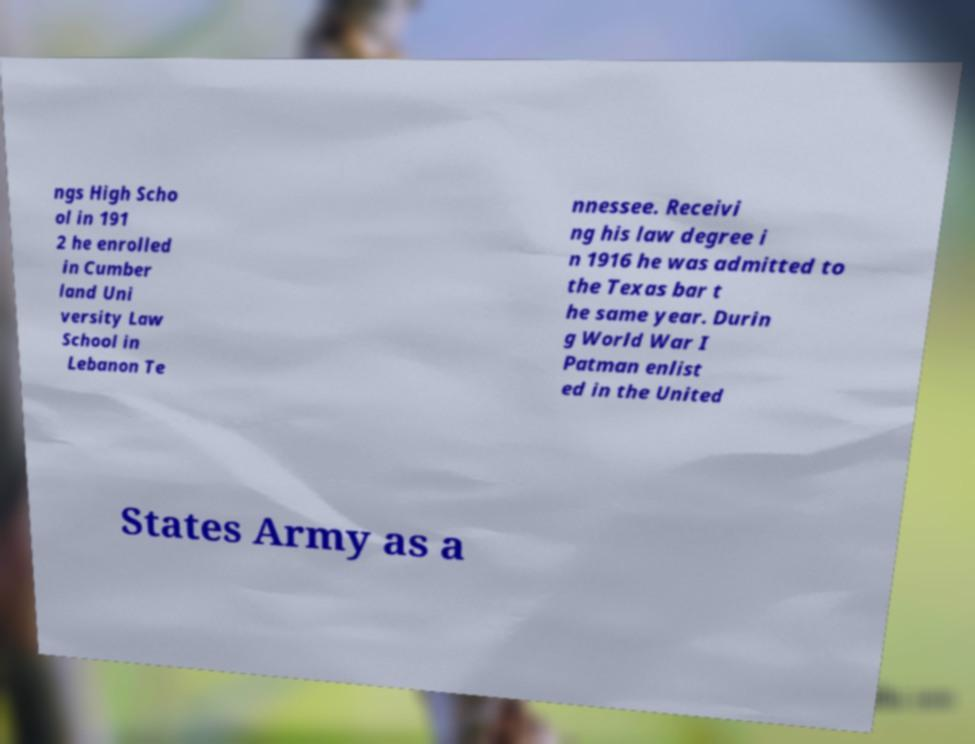There's text embedded in this image that I need extracted. Can you transcribe it verbatim? ngs High Scho ol in 191 2 he enrolled in Cumber land Uni versity Law School in Lebanon Te nnessee. Receivi ng his law degree i n 1916 he was admitted to the Texas bar t he same year. Durin g World War I Patman enlist ed in the United States Army as a 